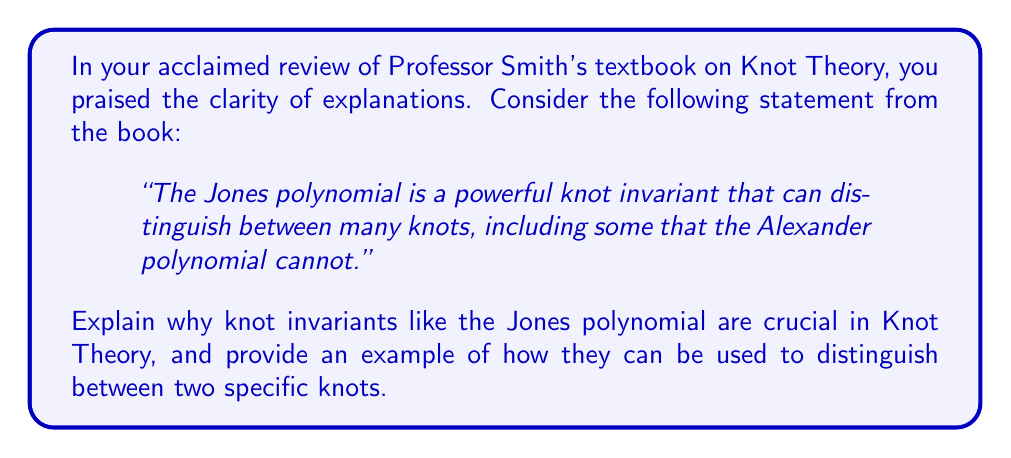Teach me how to tackle this problem. 1. Understanding knot invariants:
   - Knot invariants are mathematical quantities or properties that remain unchanged under isotopy (continuous deformation without cutting or gluing).
   - They provide a way to classify and distinguish between different knots.

2. Importance of knot invariants:
   - Knots can appear similar visually but be fundamentally different.
   - Invariants provide a rigorous mathematical method to differentiate knots.
   - They allow for the systematic classification of knots.

3. The Jones polynomial:
   - Discovered by Vaughan Jones in 1984.
   - It is a more powerful invariant than some earlier ones, like the Alexander polynomial.
   - Calculated using skein relations and bracket polynomials.

4. Example: Distinguishing the trefoil knot from the unknot
   - Let's consider the right-handed trefoil knot and the unknot.
   - The Jones polynomial for the unknot is always 1.
   - The Jones polynomial for the right-handed trefoil knot is:
     $$V_{\text{trefoil}}(t) = t + t^3 - t^4$$

5. Interpretation:
   - Since the Jones polynomials are different, we can conclude that the trefoil knot and the unknot are distinct.
   - This distinction holds even if the trefoil knot is deformed in any way without cutting.

6. Broader implications:
   - Knot invariants like the Jones polynomial have applications beyond pure mathematics.
   - They are used in studying DNA topology, statistical mechanics, and quantum field theory.
Answer: Knot invariants are crucial for distinguishing and classifying knots that may appear similar. The Jones polynomial, for example, can differentiate the trefoil knot ($$t + t^3 - t^4$$) from the unknot (1). 